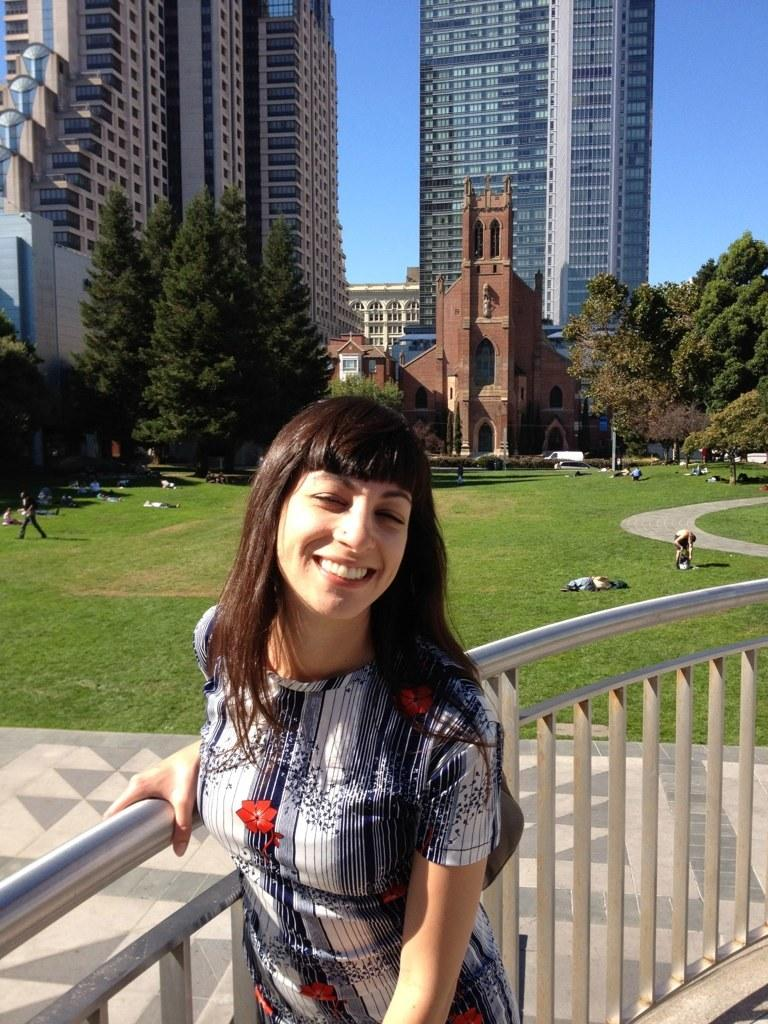What is the woman in the image doing? The woman is standing and holding an iron railing in the image. Can you describe the people in the image? There are people in the image, but their specific actions or characteristics are not mentioned in the provided facts. What can be seen on the ground in the image? There are objects on the ground in the image, but their specific nature is not mentioned in the provided facts. What is visible in the background of the image? In the background of the image, there are trees, buildings, and the sky. What sound can be heard coming from the children in the image? There is no mention of children or any sounds in the image, so it is not possible to determine what sound might be heard. 